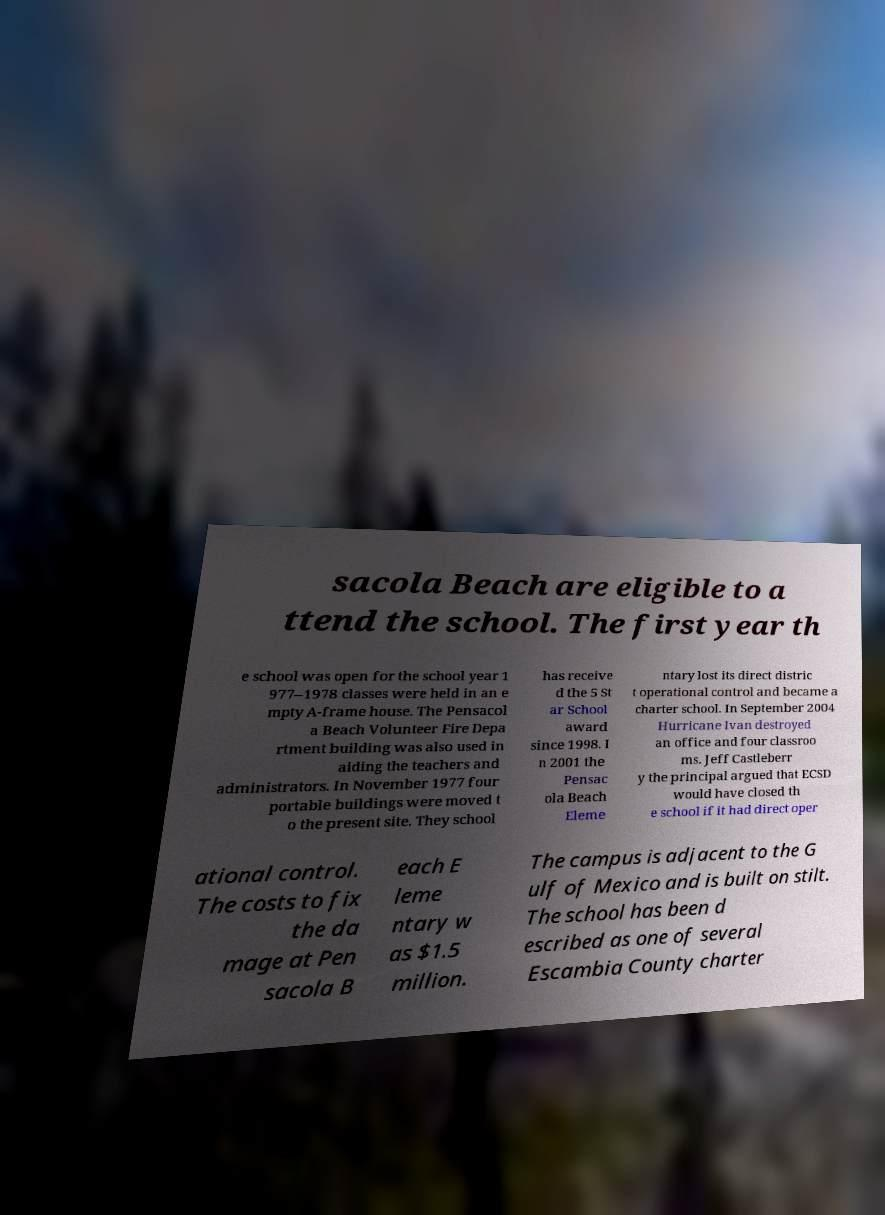Can you read and provide the text displayed in the image?This photo seems to have some interesting text. Can you extract and type it out for me? sacola Beach are eligible to a ttend the school. The first year th e school was open for the school year 1 977–1978 classes were held in an e mpty A-frame house. The Pensacol a Beach Volunteer Fire Depa rtment building was also used in aiding the teachers and administrators. In November 1977 four portable buildings were moved t o the present site. They school has receive d the 5 St ar School award since 1998. I n 2001 the Pensac ola Beach Eleme ntary lost its direct distric t operational control and became a charter school. In September 2004 Hurricane Ivan destroyed an office and four classroo ms. Jeff Castleberr y the principal argued that ECSD would have closed th e school if it had direct oper ational control. The costs to fix the da mage at Pen sacola B each E leme ntary w as $1.5 million. The campus is adjacent to the G ulf of Mexico and is built on stilt. The school has been d escribed as one of several Escambia County charter 